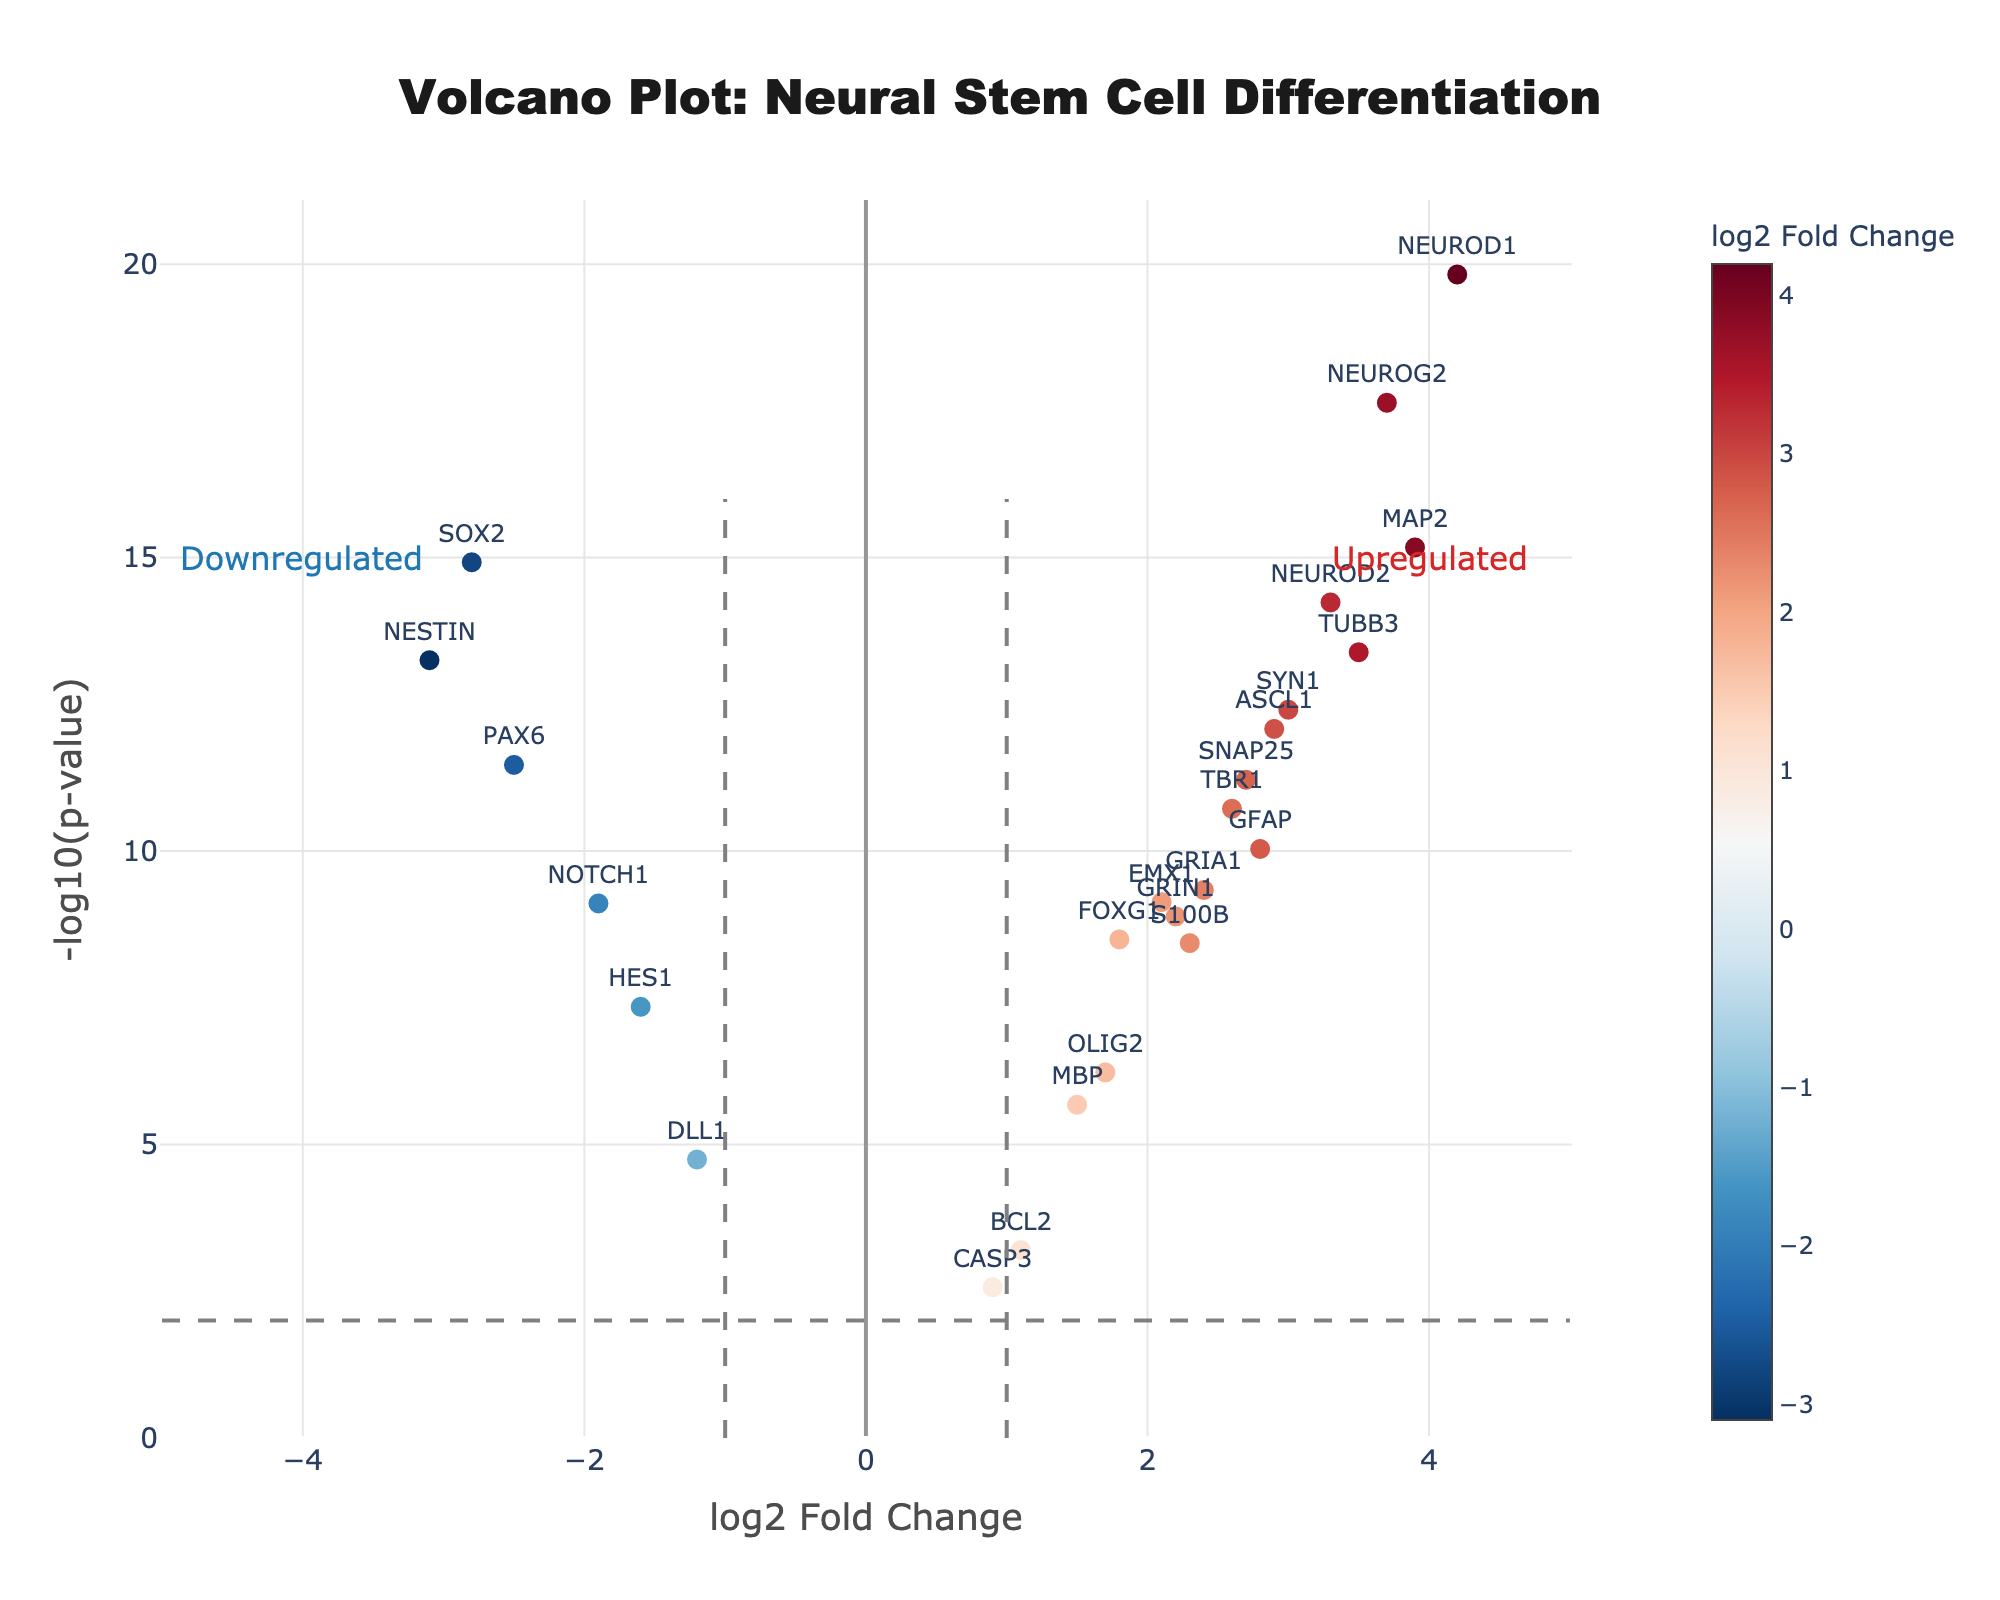What is the title of the plot? The title is located at the top center of the plot. It reads "Volcano Plot: Neural Stem Cell Differentiation."
Answer: Volcano Plot: Neural Stem Cell Differentiation How many genes have a log2 Fold Change greater than 3? By observing the x-axis, count the number of data points positioned to the right of the value 3 on the log2 Fold Change axis.
Answer: 7 Which gene has the highest -log10(p-value)? Identify the data point at the highest position on the y-axis (-log10(p-value)) and check its labeled gene name.
Answer: NEUROD1 What is the log2 Fold Change value of the SOX2 gene? Locate the gene label "SOX2," then read its x-axis (log2 Fold Change) value.
Answer: -2.8 Which genes are downregulated based on the dashed vertical line criteria? Downregulated genes are labeled to the left of the vertical line at log2 Fold Change = -1 and above the horizontal line at -log10(p-value) = 2.
Answer: SOX2, NESTIN, PAX6, NOTCH1, HES1 What is the average log2 Fold Change of the upregulated genes with a -log10(p-value) greater than 10? Identify genes with a -log10(p-value) greater than 10 on the y-axis and positive log2 Fold Change values. Add their log2 Fold Changes and divide by the number of such genes.
Answer: (3.7 + 4.2 + 3.9 + 3.3 + 3.5)/5 = 3.72 Which region of the plot (upregulated or downregulated) contains more genes? Compare the number of data points present in the upregulated region (right of log2 Fold Change = 1) and downregulated region (left of log2 Fold Change = -1).
Answer: Upregulated What is the significance threshold for p-values represented on the plot? The significance threshold is shown by the horizontal dashed line at a specific -log10(p-value) value on the y-axis.
Answer: 0.01 (which corresponds to -log10(p-value) = 2) Which gene has the closest log2 Fold Change to 0 but is still statistically significant? Find the data point closest to the center of the x-axis (log2 Fold Change = 0) while still being above the horizontal significance threshold line (-log10(p-value) = 2).
Answer: BCL2 